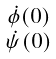<formula> <loc_0><loc_0><loc_500><loc_500>\begin{smallmatrix} \dot { \phi } ( 0 ) \\ \dot { \psi } ( 0 ) \\ \end{smallmatrix}</formula> 